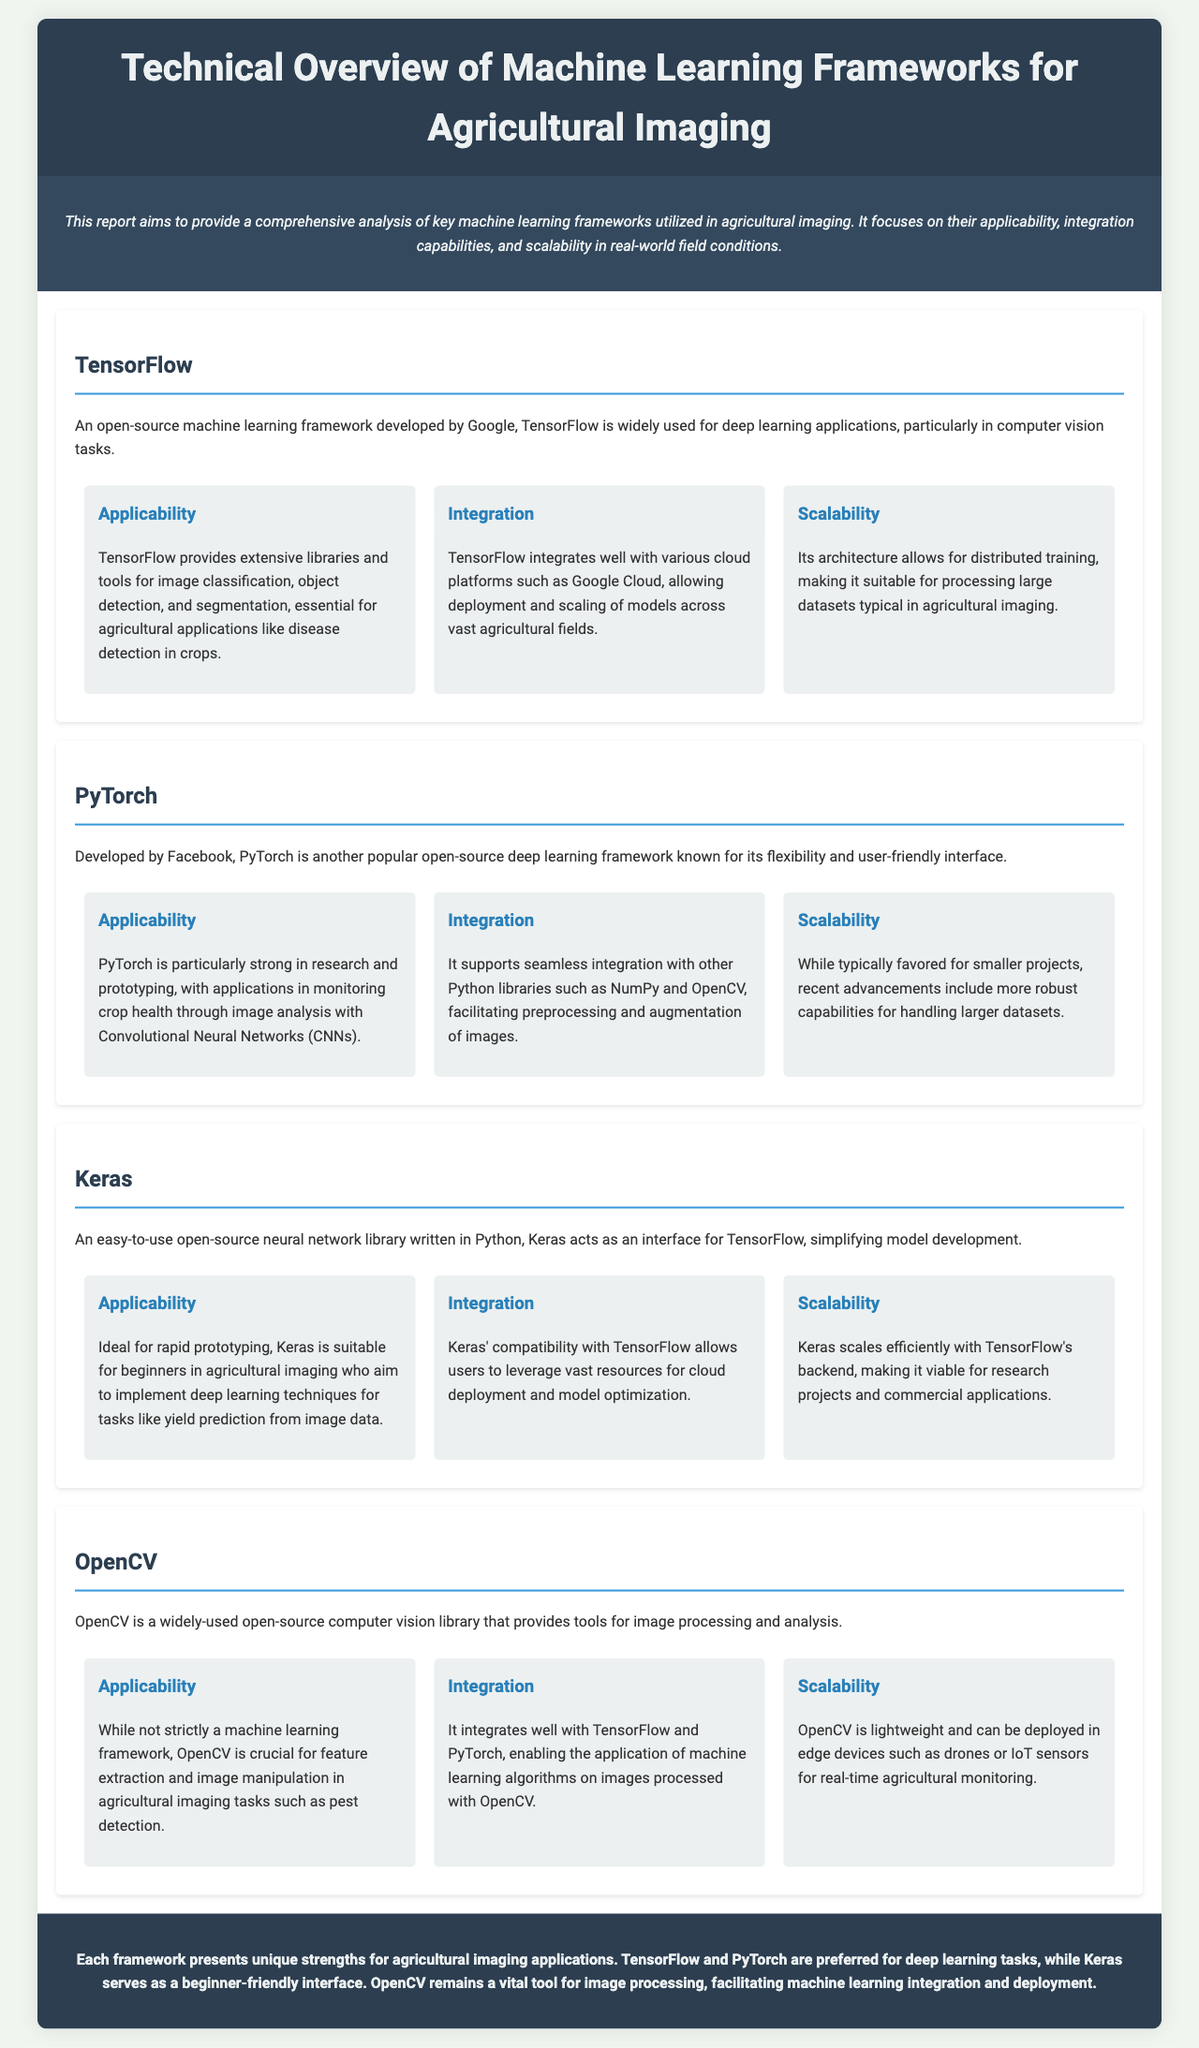what is the title of the report? The title of the report is stated at the top of the document under the header section.
Answer: Technical Overview of Machine Learning Frameworks for Agricultural Imaging who developed TensorFlow? The document clearly attributes TensorFlow's development to Google.
Answer: Google which framework is known for flexibility? The document mentions that PyTorch is known for its flexibility and user-friendly interface.
Answer: PyTorch what is a primary application of Keras mentioned in the document? Keras is described as suitable for rapid prototyping specifically for yield prediction from image data.
Answer: yield prediction how does OpenCV integrate with other frameworks? The document specifies that OpenCV integrates well with TensorFlow and PyTorch.
Answer: TensorFlow and PyTorch what is one main strength of TensorFlow mentioned? The document highlights that TensorFlow is useful for deep learning applications, particularly in computer vision tasks.
Answer: deep learning applications what type of learning does PyTorch primarily support? The document states that PyTorch is particularly strong in research and prototyping applications.
Answer: research and prototyping what is the conclusion about each framework's strengths? The conclusion summarizes that each framework has unique strengths for agricultural imaging applications.
Answer: unique strengths 